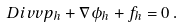<formula> <loc_0><loc_0><loc_500><loc_500>\ D i v v p _ { h } + \nabla \phi _ { h } + f _ { h } = 0 \, .</formula> 